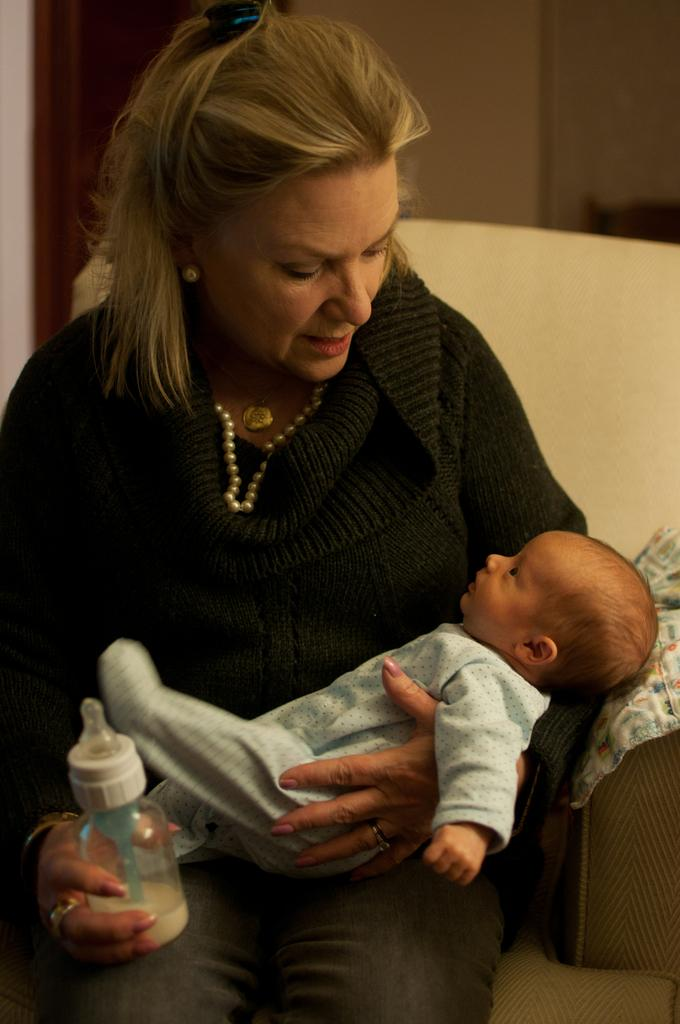What is the main subject of the image? The main subject of the image is a lady. What is the lady doing in the image? The lady is holding a baby. What else is the lady holding in the image? The lady is also holding a bottle. Where is the lady sitting in the image? The lady is sitting on a couch. What type of sleet can be seen falling outside the window in the image? There is no window or sleet visible in the image. What is the lady using to whip the baby in the image? The lady is not whipping the baby; she is holding the baby gently. 